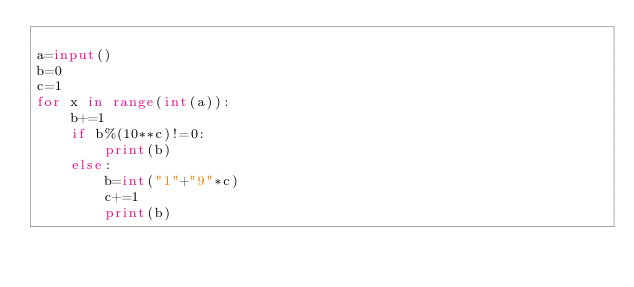<code> <loc_0><loc_0><loc_500><loc_500><_Python_>
a=input()
b=0
c=1
for x in range(int(a)):
    b+=1
    if b%(10**c)!=0:
        print(b)
    else:
        b=int("1"+"9"*c)
        c+=1
        print(b)
</code> 